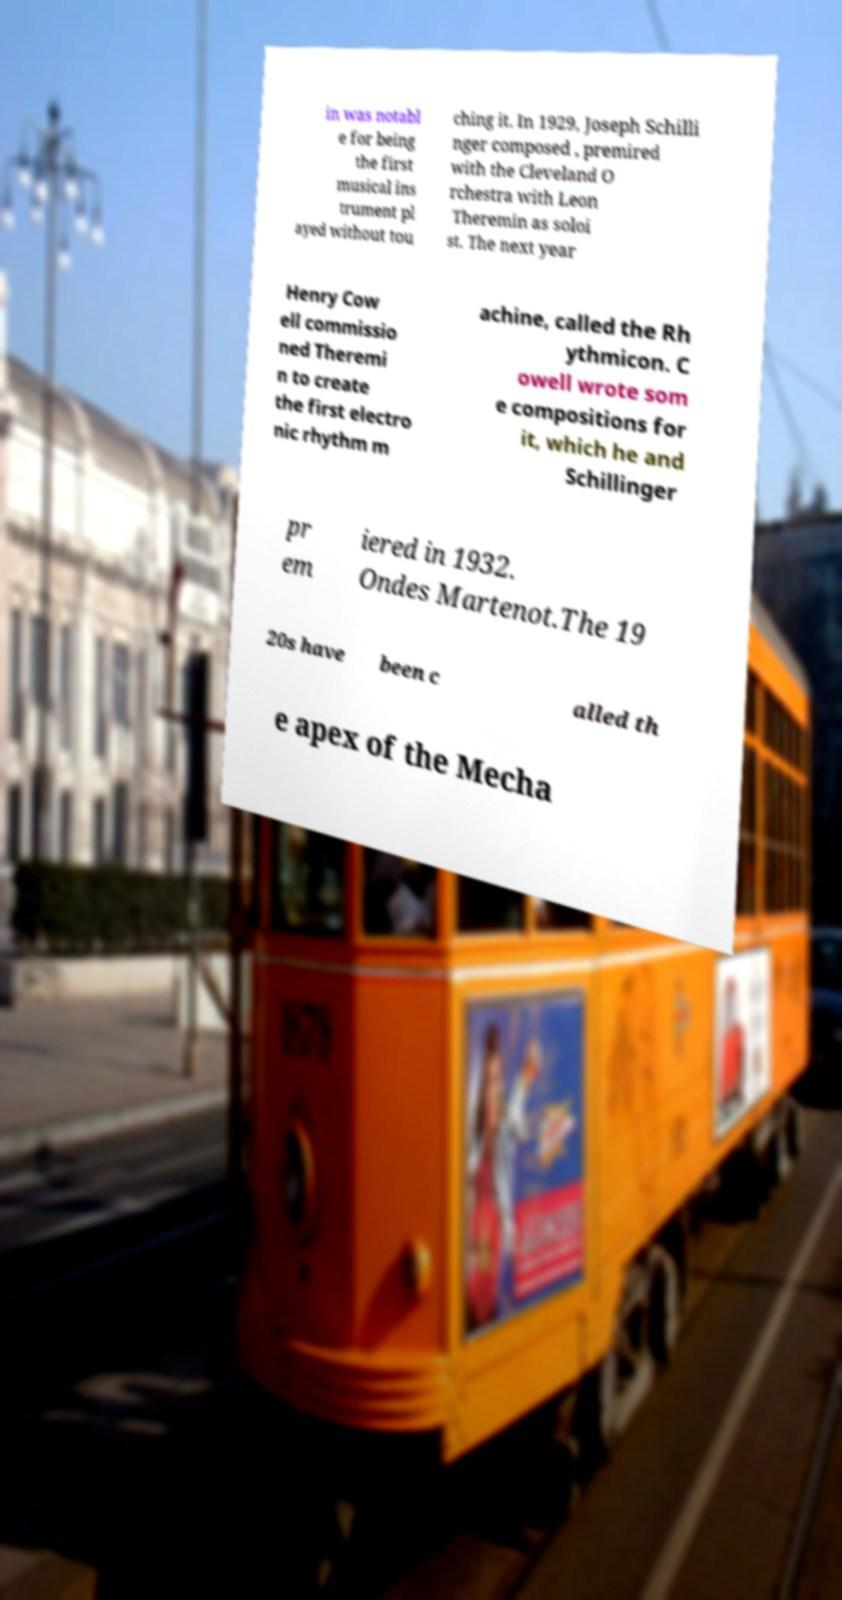I need the written content from this picture converted into text. Can you do that? in was notabl e for being the first musical ins trument pl ayed without tou ching it. In 1929, Joseph Schilli nger composed , premired with the Cleveland O rchestra with Leon Theremin as soloi st. The next year Henry Cow ell commissio ned Theremi n to create the first electro nic rhythm m achine, called the Rh ythmicon. C owell wrote som e compositions for it, which he and Schillinger pr em iered in 1932. Ondes Martenot.The 19 20s have been c alled th e apex of the Mecha 